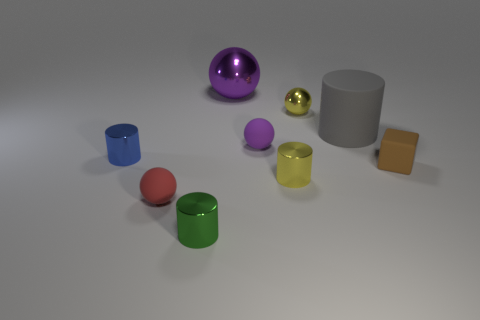Is the material of the green object the same as the large gray thing?
Make the answer very short. No. There is a large thing in front of the small shiny ball; how many yellow shiny cylinders are behind it?
Provide a succinct answer. 0. How many cyan things are rubber balls or metal balls?
Your answer should be very brief. 0. There is a shiny thing that is left of the cylinder that is in front of the tiny rubber ball to the left of the green cylinder; what is its shape?
Offer a very short reply. Cylinder. What is the color of the cylinder that is the same size as the purple shiny ball?
Give a very brief answer. Gray. How many small green objects are the same shape as the small red matte object?
Your response must be concise. 0. Is the size of the red matte sphere the same as the yellow metallic object behind the large cylinder?
Make the answer very short. Yes. What is the shape of the object that is in front of the tiny sphere that is on the left side of the purple shiny ball?
Ensure brevity in your answer.  Cylinder. Are there fewer big things that are behind the big purple metallic sphere than rubber cubes?
Keep it short and to the point. Yes. What shape is the small thing that is the same color as the tiny metallic ball?
Keep it short and to the point. Cylinder. 